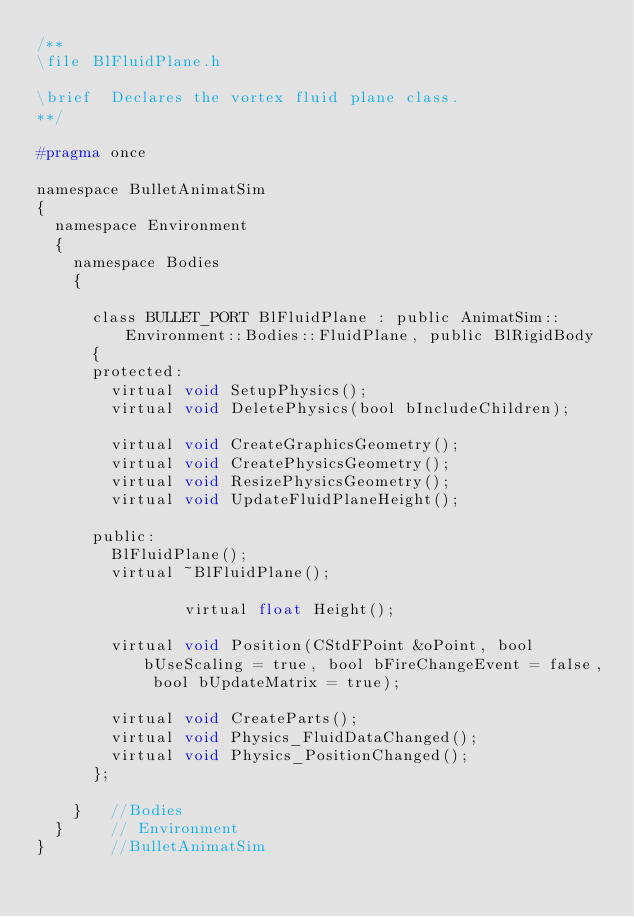<code> <loc_0><loc_0><loc_500><loc_500><_C_>/**
\file	BlFluidPlane.h

\brief	Declares the vortex fluid plane class.
**/

#pragma once

namespace BulletAnimatSim
{
	namespace Environment
	{
		namespace Bodies
		{

			class BULLET_PORT BlFluidPlane : public AnimatSim::Environment::Bodies::FluidPlane, public BlRigidBody
			{
			protected:
				virtual void SetupPhysics();
				virtual void DeletePhysics(bool bIncludeChildren);

				virtual void CreateGraphicsGeometry();
				virtual void CreatePhysicsGeometry();
				virtual void ResizePhysicsGeometry();
				virtual void UpdateFluidPlaneHeight();

			public:
				BlFluidPlane();
				virtual ~BlFluidPlane();

                virtual float Height();

				virtual void Position(CStdFPoint &oPoint, bool bUseScaling = true, bool bFireChangeEvent = false, bool bUpdateMatrix = true);

				virtual void CreateParts();
				virtual void Physics_FluidDataChanged();
				virtual void Physics_PositionChanged();
			};

		}		//Bodies
	}			// Environment
}				//BulletAnimatSim
</code> 